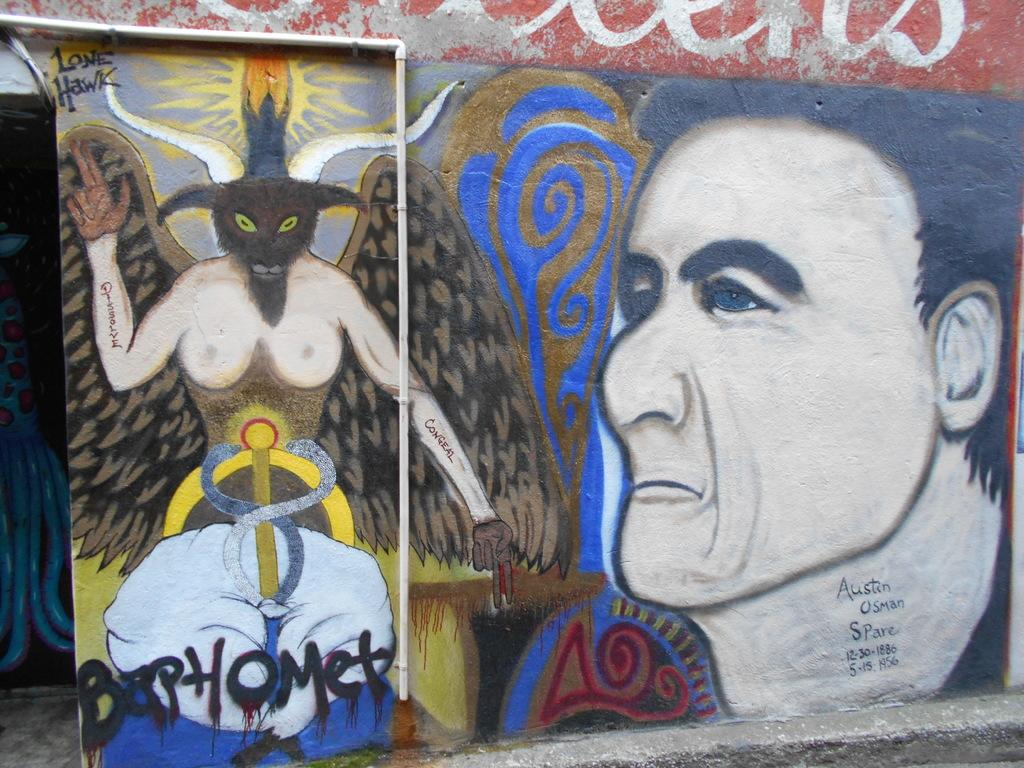What is present on the wall in the image? There is a painting on the wall in the image. What does the painting depict? The painting depicts a man and an animal. Can you describe the man in the painting? The facts provided do not give any details about the man in the painting. Can you describe the animal in the painting? The facts provided do not give any details about the animal in the painting. How many beds are visible in the image? There are no beds present in the image. What type of bead is used to create the painting? The facts provided do not mention any beads being used in the painting. 